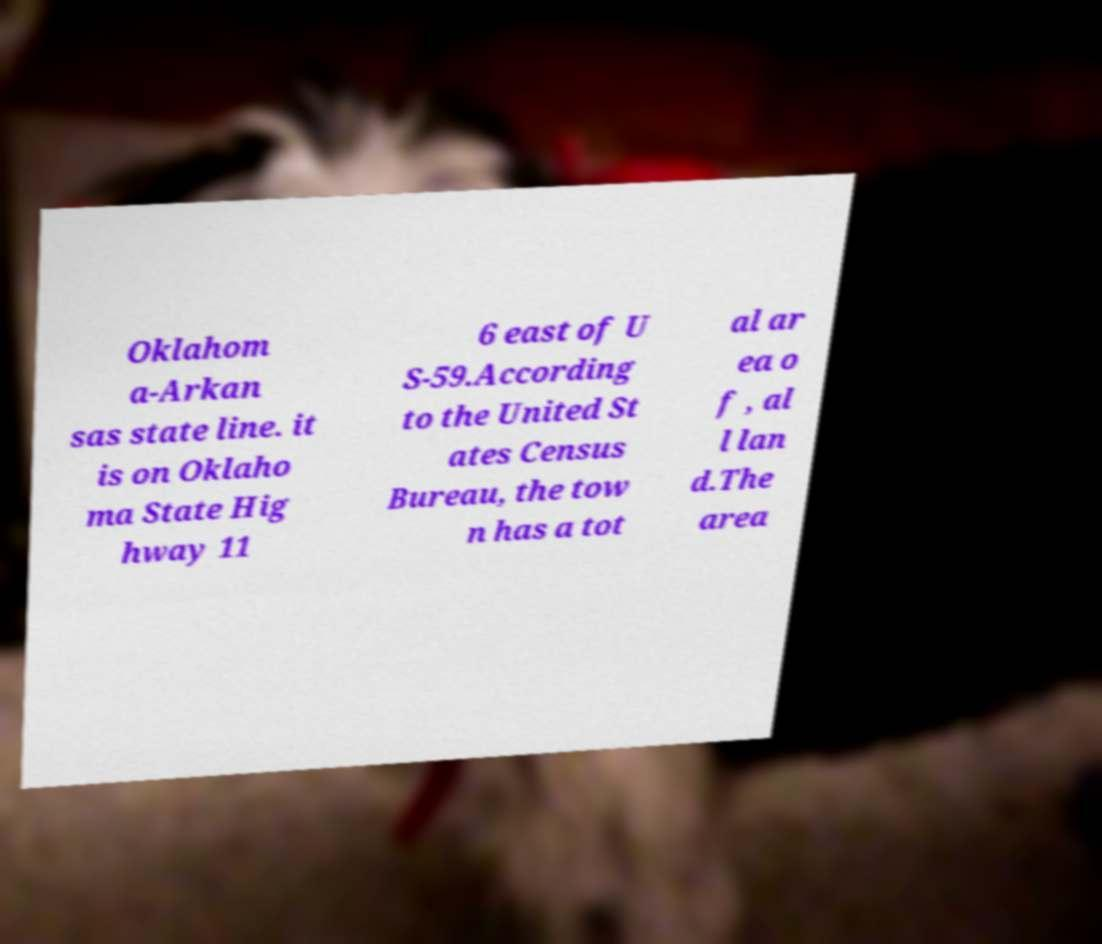Please identify and transcribe the text found in this image. Oklahom a-Arkan sas state line. it is on Oklaho ma State Hig hway 11 6 east of U S-59.According to the United St ates Census Bureau, the tow n has a tot al ar ea o f , al l lan d.The area 